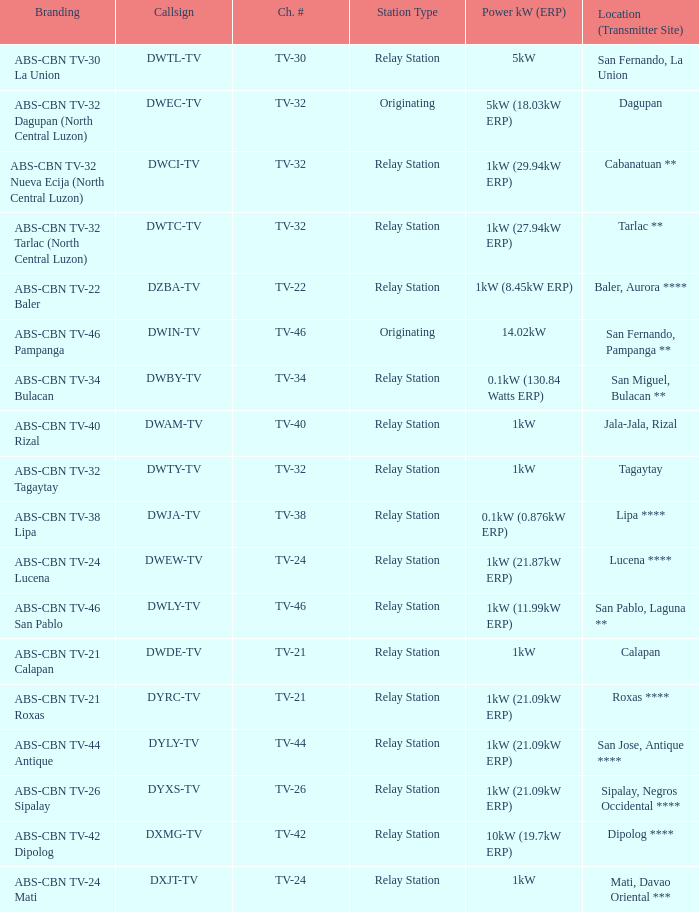What is the branding associated with the callsign dwci-tv? ABS-CBN TV-32 Nueva Ecija (North Central Luzon). 